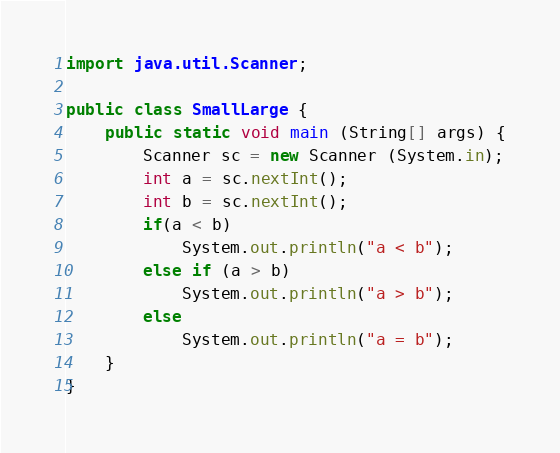<code> <loc_0><loc_0><loc_500><loc_500><_Java_>import java.util.Scanner;

public class SmallLarge {
	public static void main (String[] args) {
		Scanner sc = new Scanner (System.in);
		int a = sc.nextInt();
		int b = sc.nextInt();
		if(a < b)
			System.out.println("a < b");
		else if (a > b)
			System.out.println("a > b");
		else
			System.out.println("a = b");
	}
}</code> 